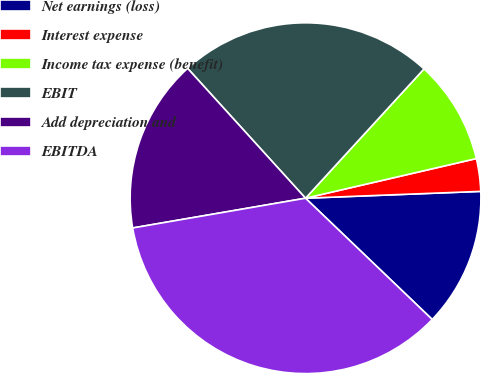<chart> <loc_0><loc_0><loc_500><loc_500><pie_chart><fcel>Net earnings (loss)<fcel>Interest expense<fcel>Income tax expense (benefit)<fcel>EBIT<fcel>Add depreciation and<fcel>EBITDA<nl><fcel>12.77%<fcel>3.01%<fcel>9.56%<fcel>23.54%<fcel>15.98%<fcel>35.13%<nl></chart> 